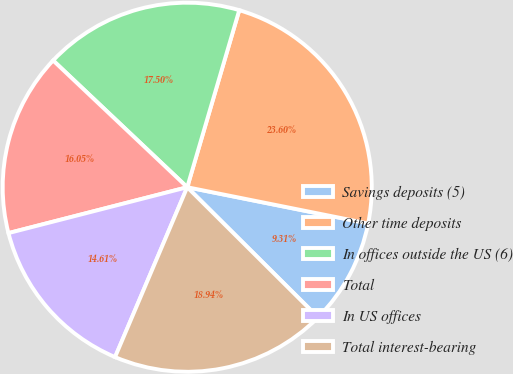Convert chart to OTSL. <chart><loc_0><loc_0><loc_500><loc_500><pie_chart><fcel>Savings deposits (5)<fcel>Other time deposits<fcel>In offices outside the US (6)<fcel>Total<fcel>In US offices<fcel>Total interest-bearing<nl><fcel>9.31%<fcel>23.6%<fcel>17.5%<fcel>16.05%<fcel>14.61%<fcel>18.94%<nl></chart> 